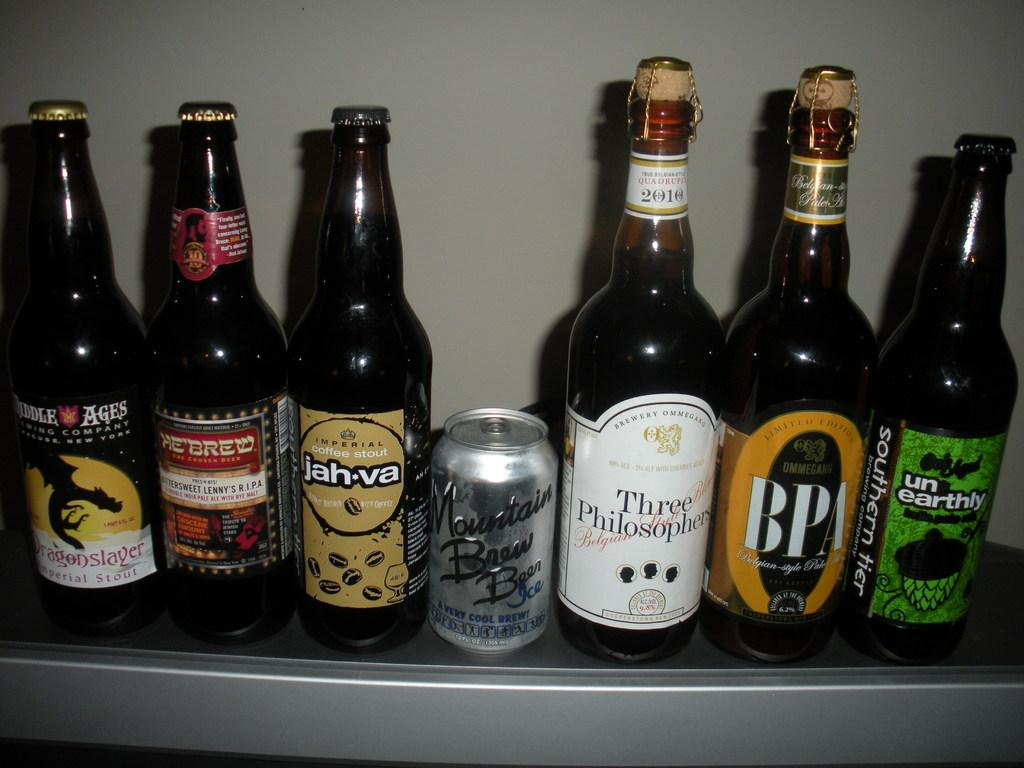<image>
Summarize the visual content of the image. A bottle of Southern Tier beer is at the end of a line of different beers. 